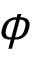Convert formula to latex. <formula><loc_0><loc_0><loc_500><loc_500>\phi</formula> 